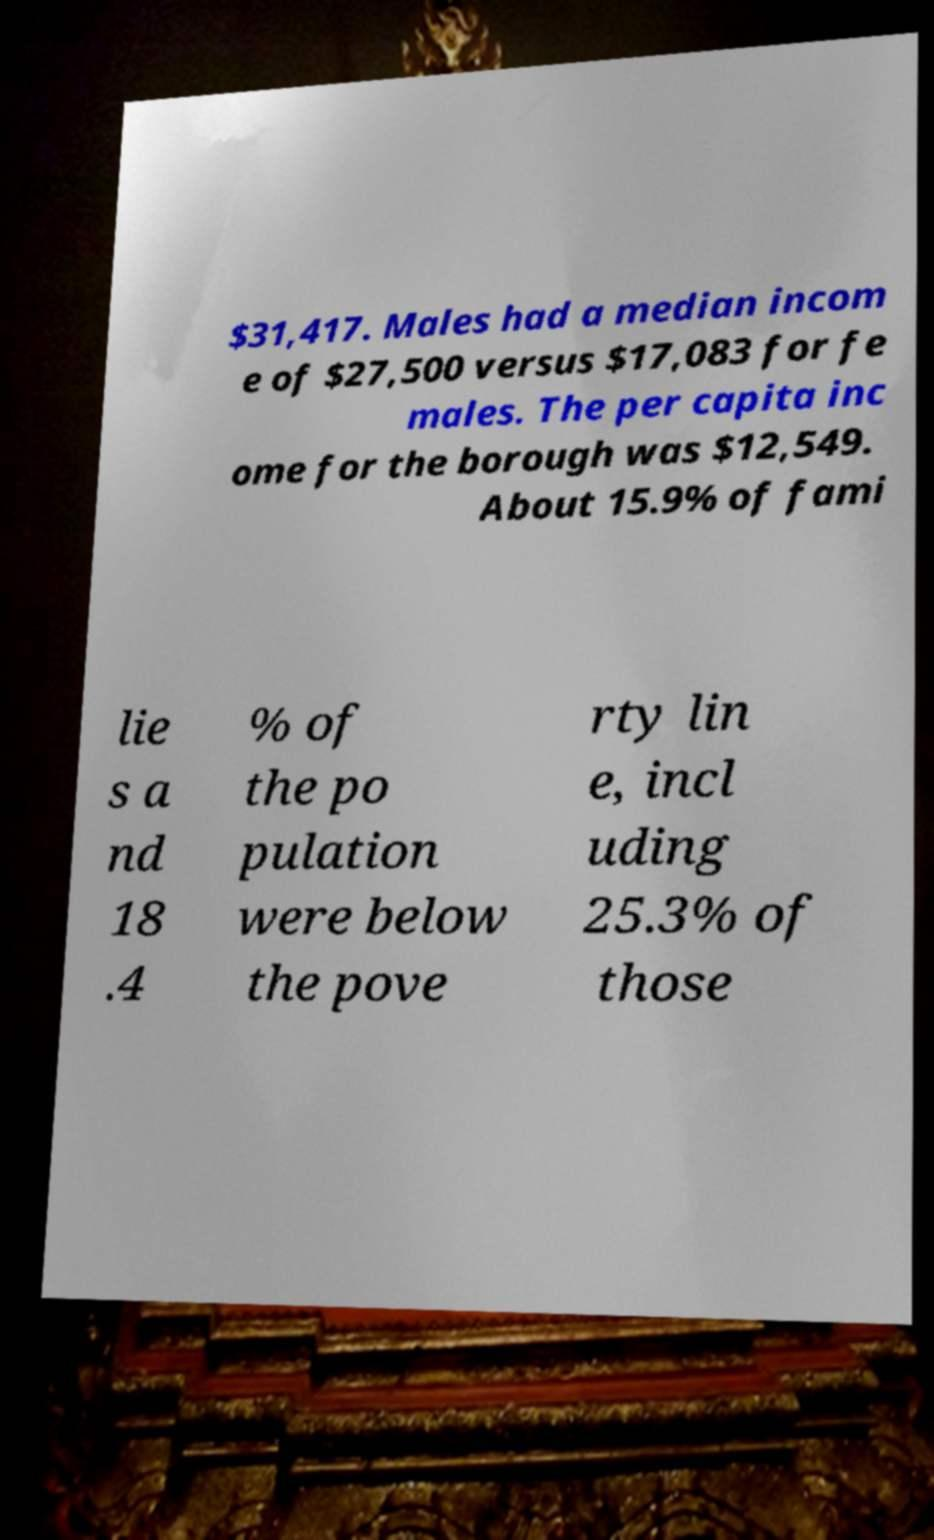There's text embedded in this image that I need extracted. Can you transcribe it verbatim? $31,417. Males had a median incom e of $27,500 versus $17,083 for fe males. The per capita inc ome for the borough was $12,549. About 15.9% of fami lie s a nd 18 .4 % of the po pulation were below the pove rty lin e, incl uding 25.3% of those 